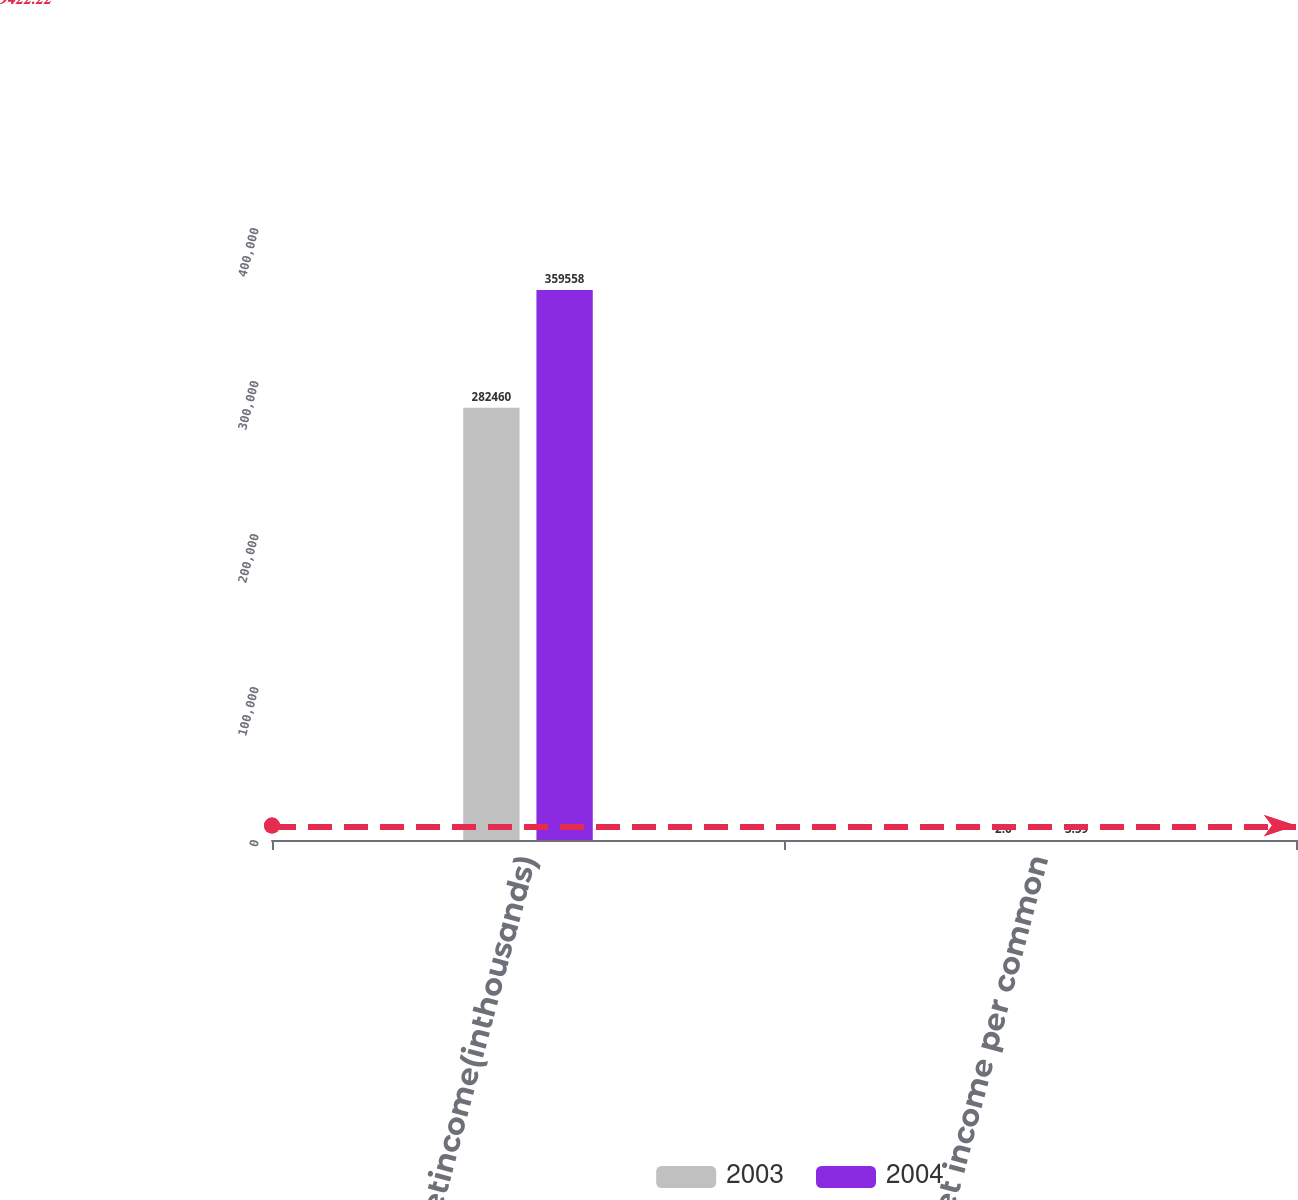Convert chart to OTSL. <chart><loc_0><loc_0><loc_500><loc_500><stacked_bar_chart><ecel><fcel>Netincome(inthousands)<fcel>Net income per common<nl><fcel>2003<fcel>282460<fcel>2.6<nl><fcel>2004<fcel>359558<fcel>3.59<nl></chart> 